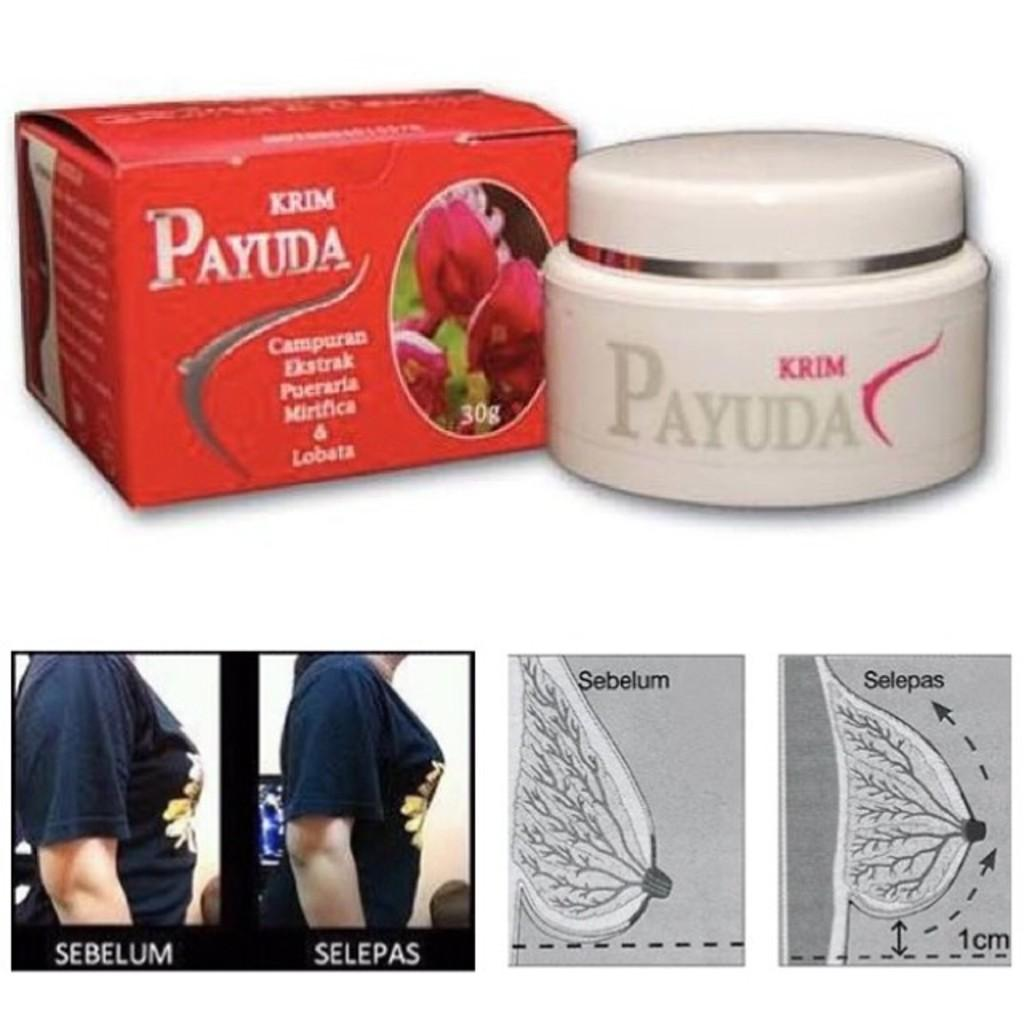<image>
Describe the image concisely. An advertisement for a breast product called Krim Payuda 